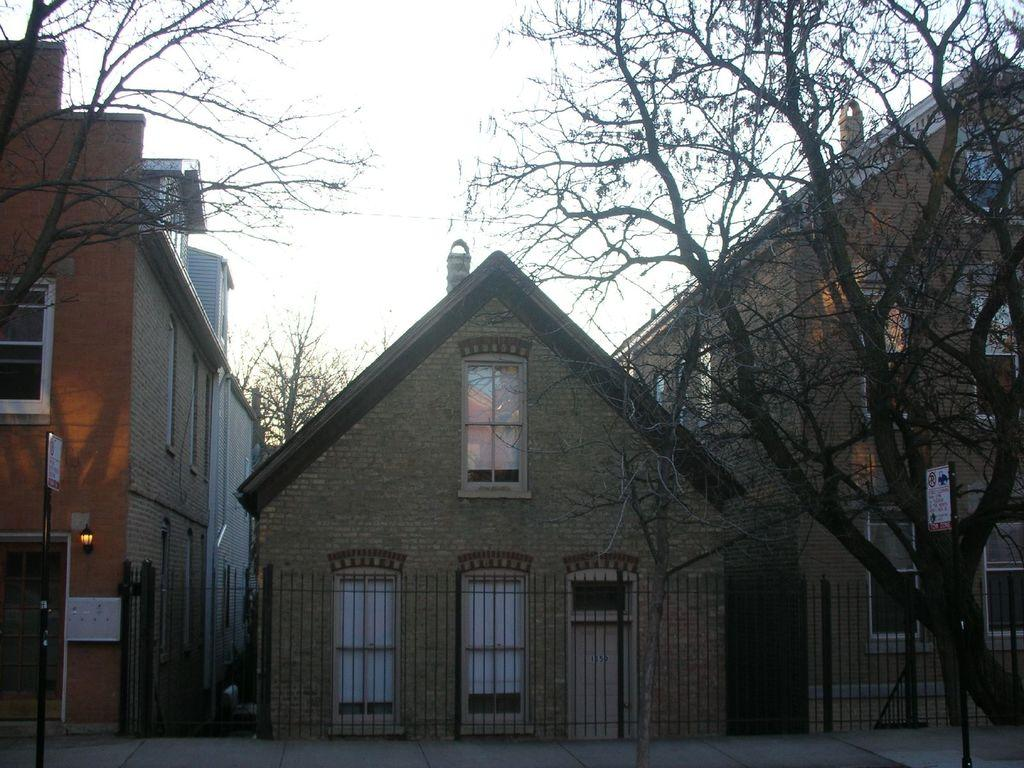What types of structures are visible in the image? There are buildings in the image. What natural elements can be seen in the image? There are trees in the image. What objects are present in the image that might be used for displaying information or advertisements? There are boards in the image. What objects are present in the image that might be used for supporting or stabilizing other structures? There are poles in the image. What objects are present in the image that might provide illumination? There are lights in the image. What type of barrier is visible in the image? There is a fence in the image. What surface is visible at the bottom of the image? The bottom of the image contains a floor. What part of the natural environment is visible at the top of the image? The top of the image contains the sky. Can you tell me how many frames are visible in the image? There are no frames present in the image; it is a single image without any framing devices. What type of mother is depicted in the image? There is no mother or any human figures present in the image. 